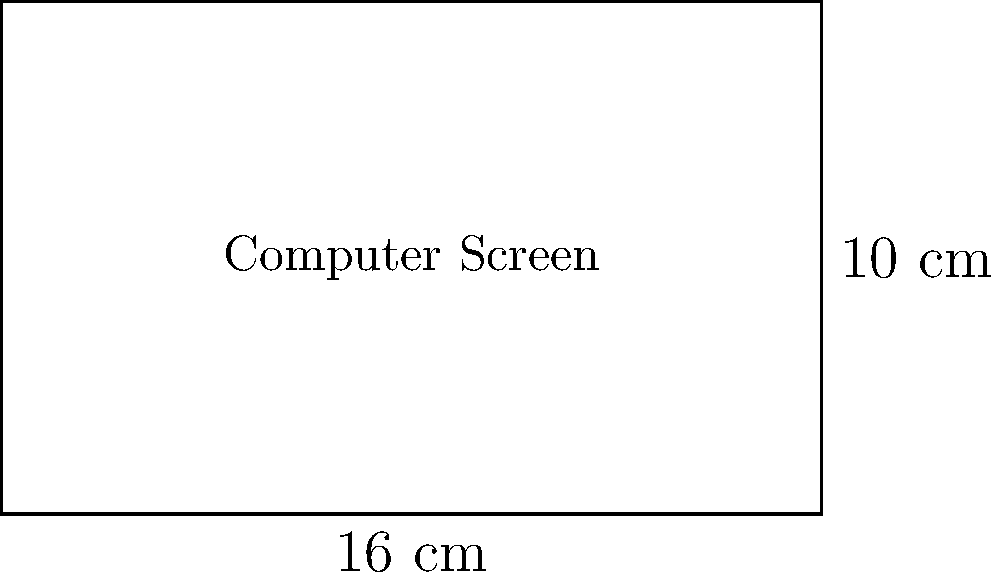A rectangular computer screen has dimensions of 16 cm by 10 cm. Calculate the area of the screen in square centimeters and its perimeter in centimeters. What is the ratio of the area to the perimeter? Let's approach this step-by-step:

1. Calculate the area:
   Area = length × width
   $A = 16 \text{ cm} \times 10 \text{ cm} = 160 \text{ cm}^2$

2. Calculate the perimeter:
   Perimeter = 2 × (length + width)
   $P = 2 \times (16 \text{ cm} + 10 \text{ cm}) = 2 \times 26 \text{ cm} = 52 \text{ cm}$

3. Calculate the ratio of area to perimeter:
   Ratio = Area ÷ Perimeter
   $R = \frac{160 \text{ cm}^2}{52 \text{ cm}} = \frac{40 \text{ cm}^2}{13 \text{ cm}} \approx 3.08 \text{ cm}$

Therefore, the area is 160 cm², the perimeter is 52 cm, and the ratio of area to perimeter is 40/13 cm ≈ 3.08 cm.
Answer: Area: 160 cm², Perimeter: 52 cm, Ratio: 40/13 cm ≈ 3.08 cm 